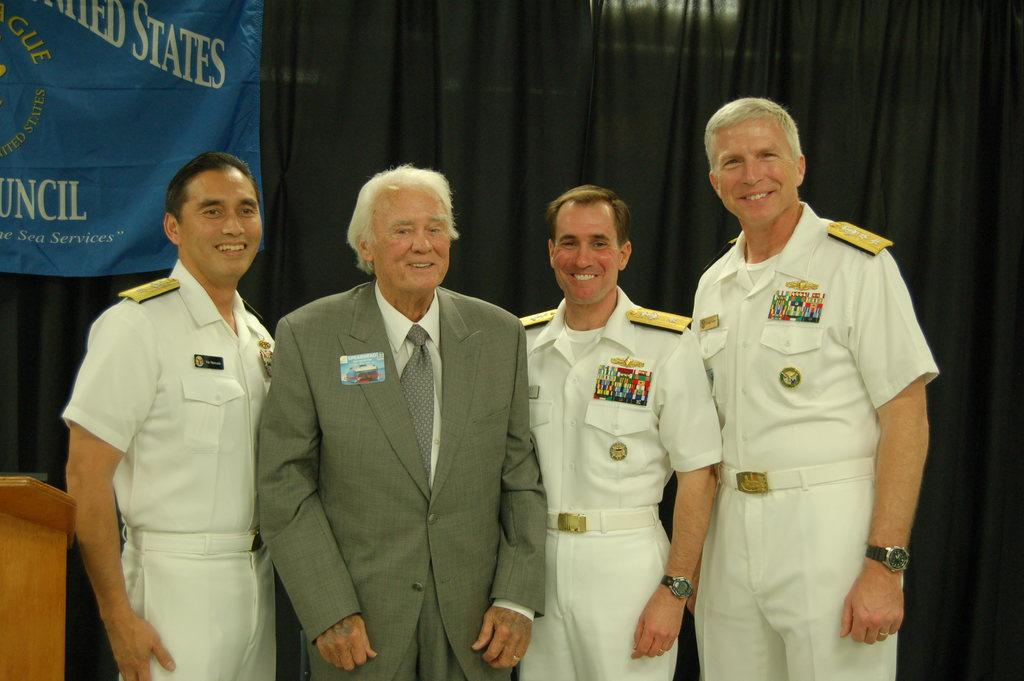<image>
Share a concise interpretation of the image provided. Four men stand in front of United States banner 